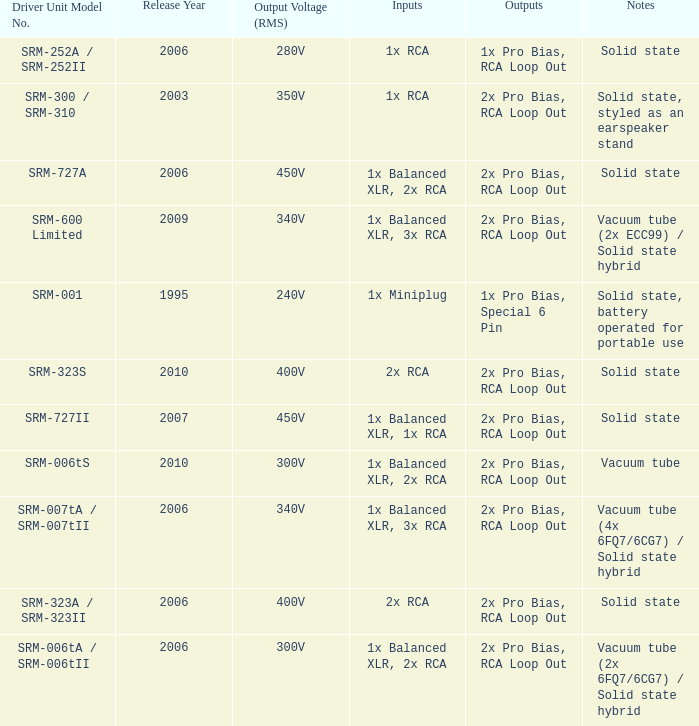What year were outputs is 2x pro bias, rca loop out and notes is vacuum tube released? 2010.0. 